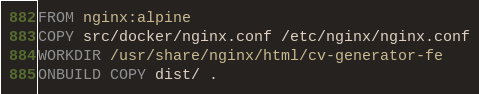Convert code to text. <code><loc_0><loc_0><loc_500><loc_500><_Dockerfile_>FROM nginx:alpine
COPY src/docker/nginx.conf /etc/nginx/nginx.conf
WORKDIR /usr/share/nginx/html/cv-generator-fe
ONBUILD COPY dist/ .
</code> 